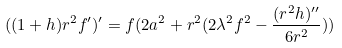<formula> <loc_0><loc_0><loc_500><loc_500>( ( 1 + h ) r ^ { 2 } f ^ { \prime } ) ^ { \prime } = f ( 2 a ^ { 2 } + r ^ { 2 } ( 2 \lambda ^ { 2 } f ^ { 2 } - \frac { ( r ^ { 2 } h ) ^ { \prime \prime } } { 6 r ^ { 2 } } ) )</formula> 